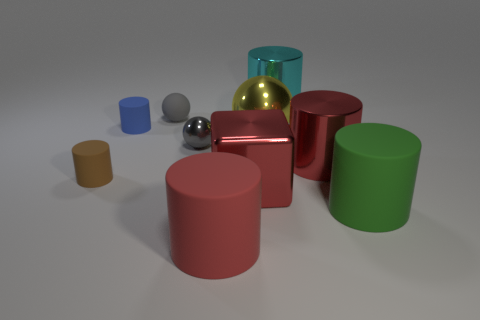What shape is the tiny object that is the same material as the red cube? sphere 